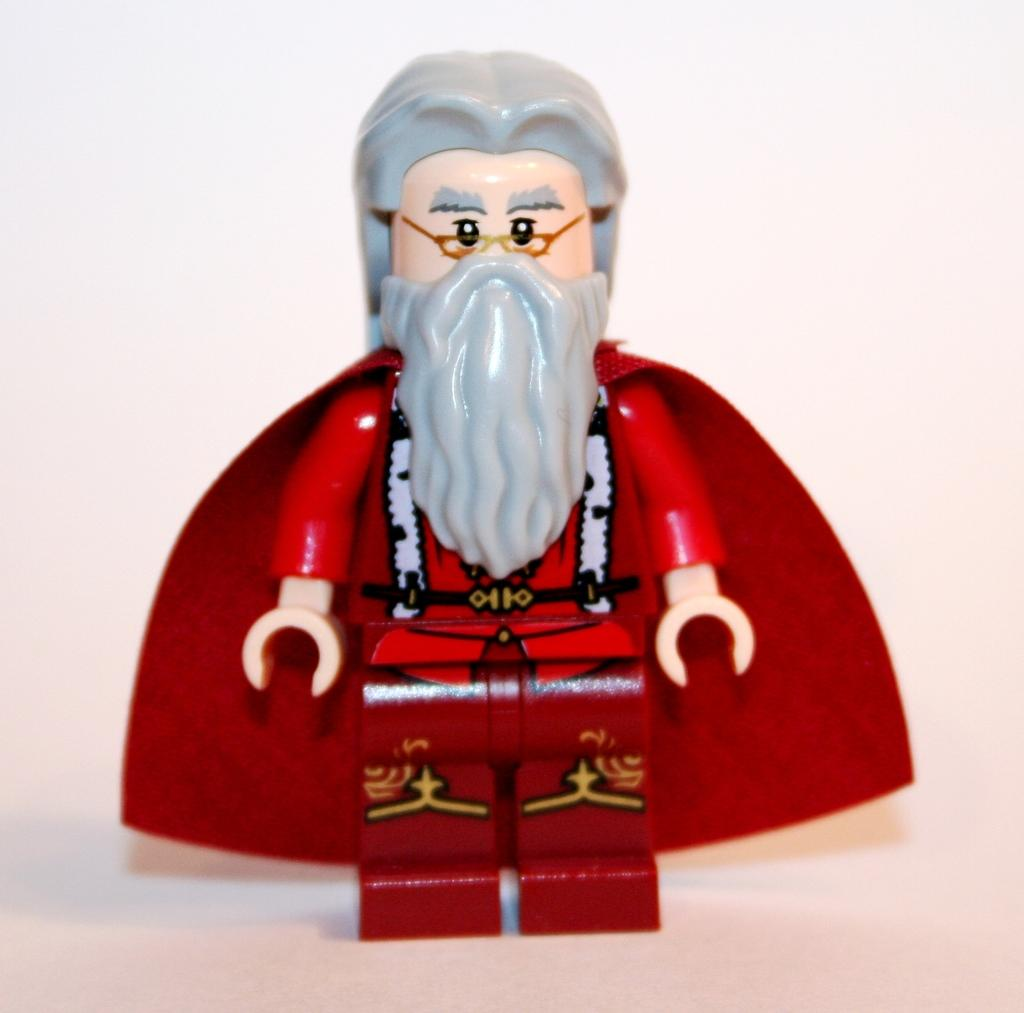What object can be seen in the image? There is a toy in the image. What is the color of the surface behind the toy? The surface in the background of the image is white. What type of trip can be seen in the image? There is no trip present in the image; it features a toy on a white surface. What substance is being used to make the oatmeal in the image? There is no oatmeal present in the image; it features a toy on a white surface. 